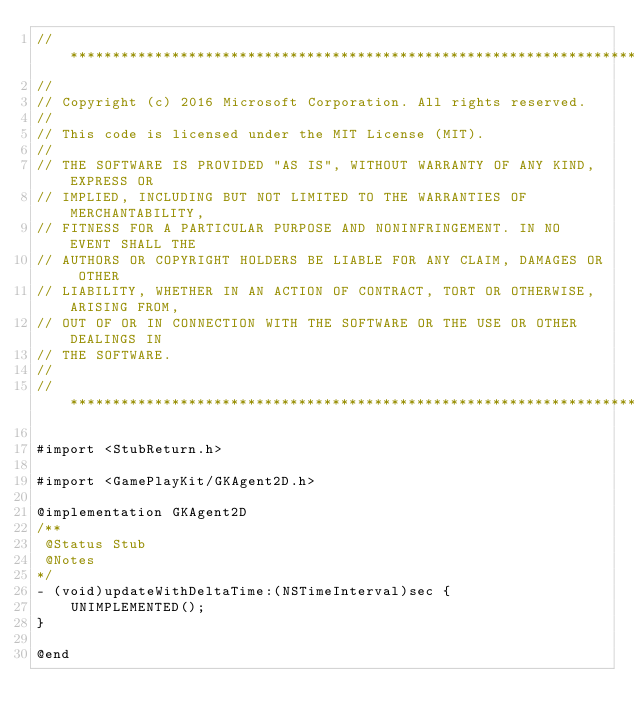Convert code to text. <code><loc_0><loc_0><loc_500><loc_500><_ObjectiveC_>//******************************************************************************
//
// Copyright (c) 2016 Microsoft Corporation. All rights reserved.
//
// This code is licensed under the MIT License (MIT).
//
// THE SOFTWARE IS PROVIDED "AS IS", WITHOUT WARRANTY OF ANY KIND, EXPRESS OR
// IMPLIED, INCLUDING BUT NOT LIMITED TO THE WARRANTIES OF MERCHANTABILITY,
// FITNESS FOR A PARTICULAR PURPOSE AND NONINFRINGEMENT. IN NO EVENT SHALL THE
// AUTHORS OR COPYRIGHT HOLDERS BE LIABLE FOR ANY CLAIM, DAMAGES OR OTHER
// LIABILITY, WHETHER IN AN ACTION OF CONTRACT, TORT OR OTHERWISE, ARISING FROM,
// OUT OF OR IN CONNECTION WITH THE SOFTWARE OR THE USE OR OTHER DEALINGS IN
// THE SOFTWARE.
//
//******************************************************************************

#import <StubReturn.h>

#import <GamePlayKit/GKAgent2D.h>

@implementation GKAgent2D
/**
 @Status Stub
 @Notes
*/
- (void)updateWithDeltaTime:(NSTimeInterval)sec {
    UNIMPLEMENTED();
}

@end
</code> 